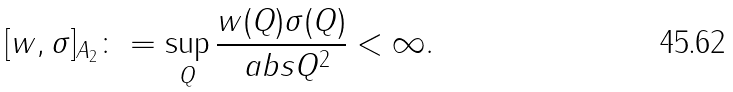Convert formula to latex. <formula><loc_0><loc_0><loc_500><loc_500>[ w , \sigma ] _ { A _ { 2 } } \colon = \sup _ { Q } \frac { w ( Q ) \sigma ( Q ) } { \ a b s { Q } ^ { 2 } } < \infty .</formula> 